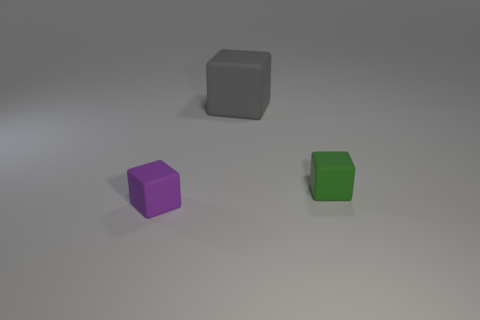How many other things are there of the same shape as the tiny purple rubber thing?
Offer a terse response. 2. Is there any other thing that is made of the same material as the tiny purple cube?
Provide a short and direct response. Yes. What color is the small block that is behind the small matte thing to the left of the small block behind the small purple rubber cube?
Provide a short and direct response. Green. Is the shape of the tiny object right of the big gray block the same as  the tiny purple rubber object?
Provide a short and direct response. Yes. How many gray rubber things are there?
Your answer should be very brief. 1. What number of green cubes are the same size as the green rubber object?
Keep it short and to the point. 0. What is the tiny green block made of?
Offer a very short reply. Rubber. Do the big rubber block and the thing in front of the green block have the same color?
Your response must be concise. No. Are there any other things that have the same size as the gray matte thing?
Provide a succinct answer. No. What size is the matte object that is both in front of the large gray thing and on the left side of the green thing?
Your answer should be compact. Small. 